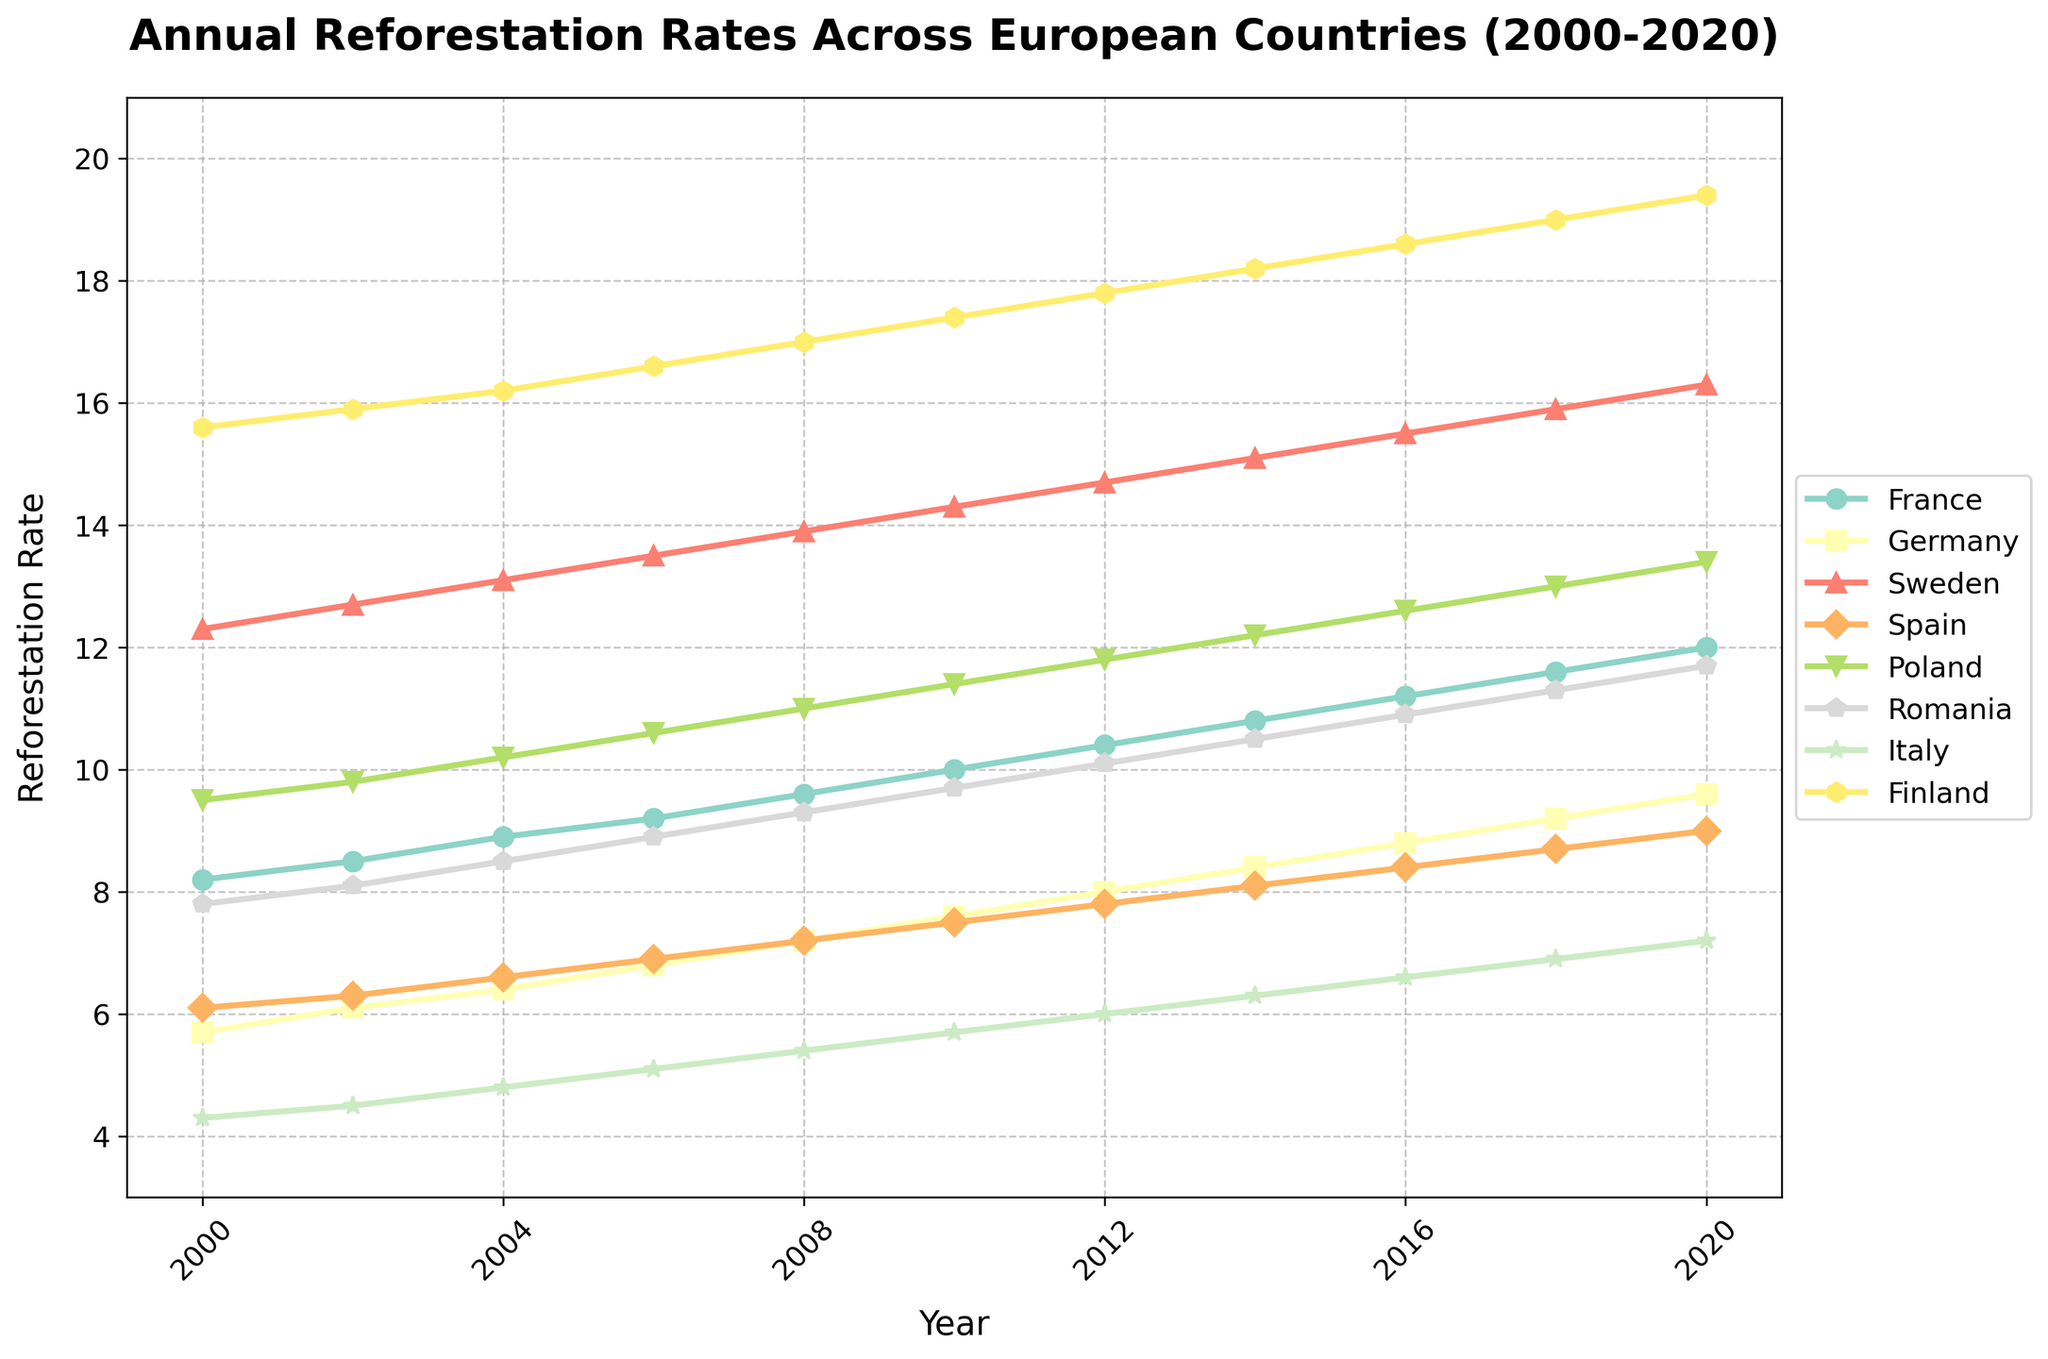What is the trend in reforestation rates for France from 2000 to 2020? To identify the trend, observe the plotted line for France. It consistently increases from 8.2 in 2000 to 12.0 in 2020, indicating a steady rise in reforestation rates over the 20 years.
Answer: Steady increase Which country had the highest reforestation rate in 2020? Check the lines at the 2020 mark. Finland has the highest value of 19.4, which is represented by the topmost line.
Answer: Finland How much did Germany's reforestation rate increase from 2000 to 2020? Look at Germany's values in 2000 (5.7) and 2020 (9.6). Subtract the former from the latter: 9.6 - 5.7 = 3.9.
Answer: 3.9 Between which consecutive years did Sweden see the largest increase in reforestation rate? Examine the increments in Sweden's data between each pair of consecutive years. The largest increase is between 2006 (13.5) and 2008 (13.9), which is 0.4.
Answer: 2006-2008 What is the average reforestation rate for Spain over the period 2000-2020? Sum all the values for Spain (6.1 + 6.3 + 6.6 + 6.9 + 7.2 + 7.5 + 7.8 + 8.1 + 8.4 + 8.7 + 9.0 = 82.6). Then divide by the number of years (11): 82.6 / 11 = 7.51.
Answer: 7.51 Which country had the most consistent reforestation rate growth over the 20 years? Visualize the smoothness and consistency of the lines. France's line exhibits the most uniform increase without significant dips or spikes.
Answer: France How does the reforestation rate in Poland in 2010 compare to that in Romania in 2008? Compare the values for Poland in 2010 (11.4) and Romania in 2008 (9.3). Poland's rate is higher.
Answer: Poland is higher Which country showed the maximum variance in reforestation rates from 2000 to 2020? Assess fluctuations in the plotted lines. Finland displays the most variation, ranging from 15.6 in 2000 to 19.4 in 2020.
Answer: Finland How much did Italy's reforestation rate increase from 2000 to 2004? Compare the values for Italy in 2000 (4.3) and 2004 (4.8). Subtract the former from the latter: 4.8 - 4.3 = 0.5.
Answer: 0.5 